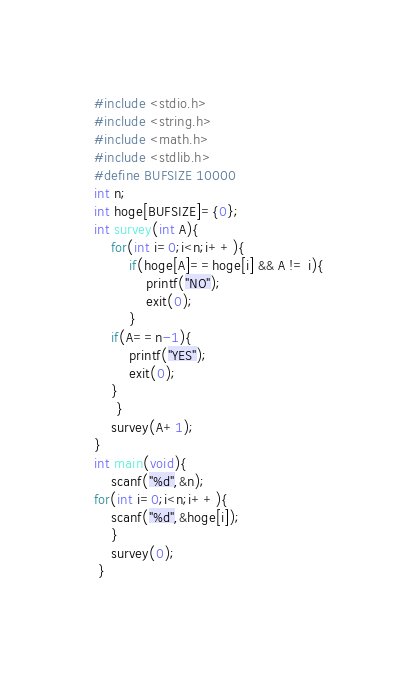<code> <loc_0><loc_0><loc_500><loc_500><_C_>#include <stdio.h>
#include <string.h>
#include <math.h>
#include <stdlib.h>
#define BUFSIZE 10000
int n;
int hoge[BUFSIZE]={0};
int survey(int A){
    for(int i=0;i<n;i++){    
        if(hoge[A]==hoge[i] && A != i){
            printf("NO");
            exit(0);
        }
    if(A==n-1){
        printf("YES");
        exit(0);
    }
     }
    survey(A+1);    
}
int main(void){
    scanf("%d",&n);
for(int i=0;i<n;i++){
    scanf("%d",&hoge[i]);
    }
    survey(0);
 }</code> 